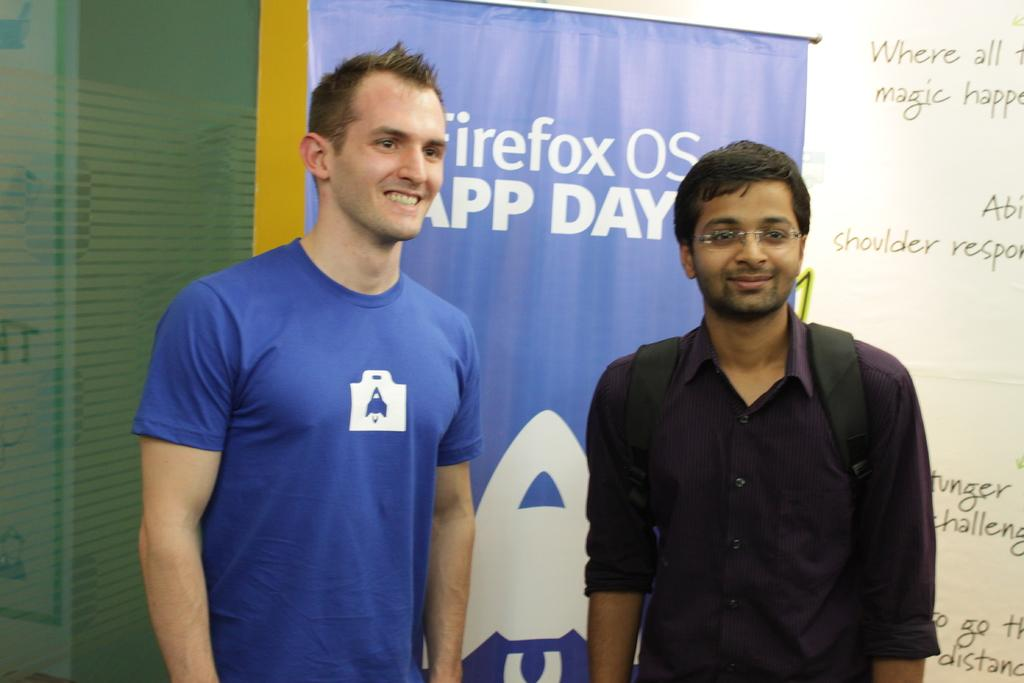<image>
Share a concise interpretation of the image provided. Two men standing in front of a blue banner which says Firefox OS. 